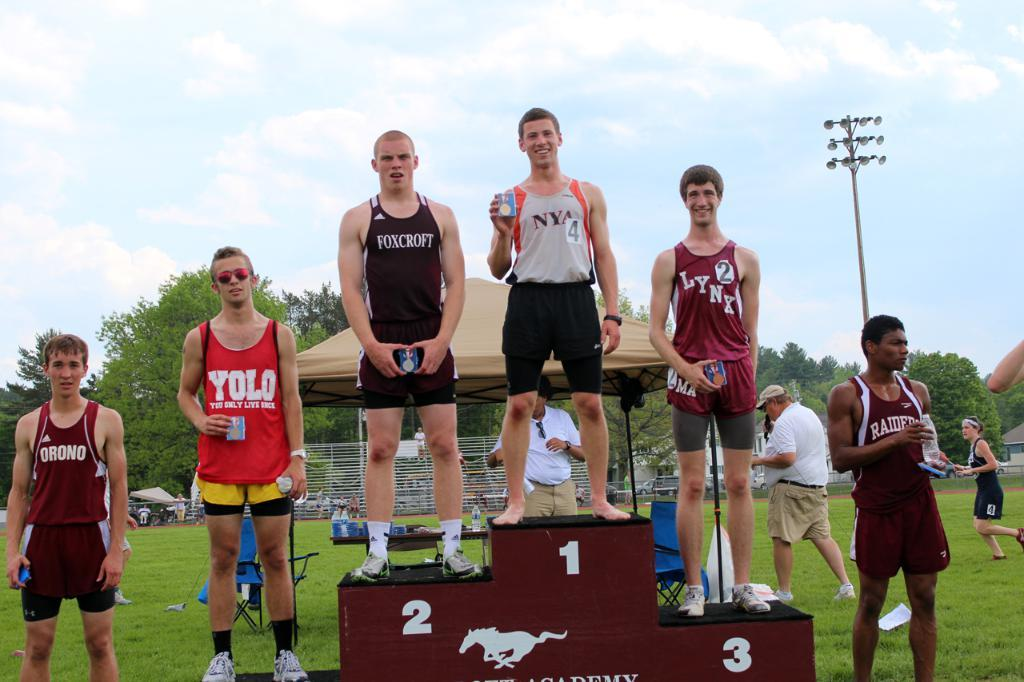<image>
Present a compact description of the photo's key features. Three boys standing on a podium with the one in first place having the nyc logo on his shirt. 